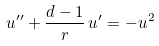Convert formula to latex. <formula><loc_0><loc_0><loc_500><loc_500>u ^ { \prime \prime } + \frac { d - 1 } { r } \, u ^ { \prime } = - u ^ { 2 }</formula> 